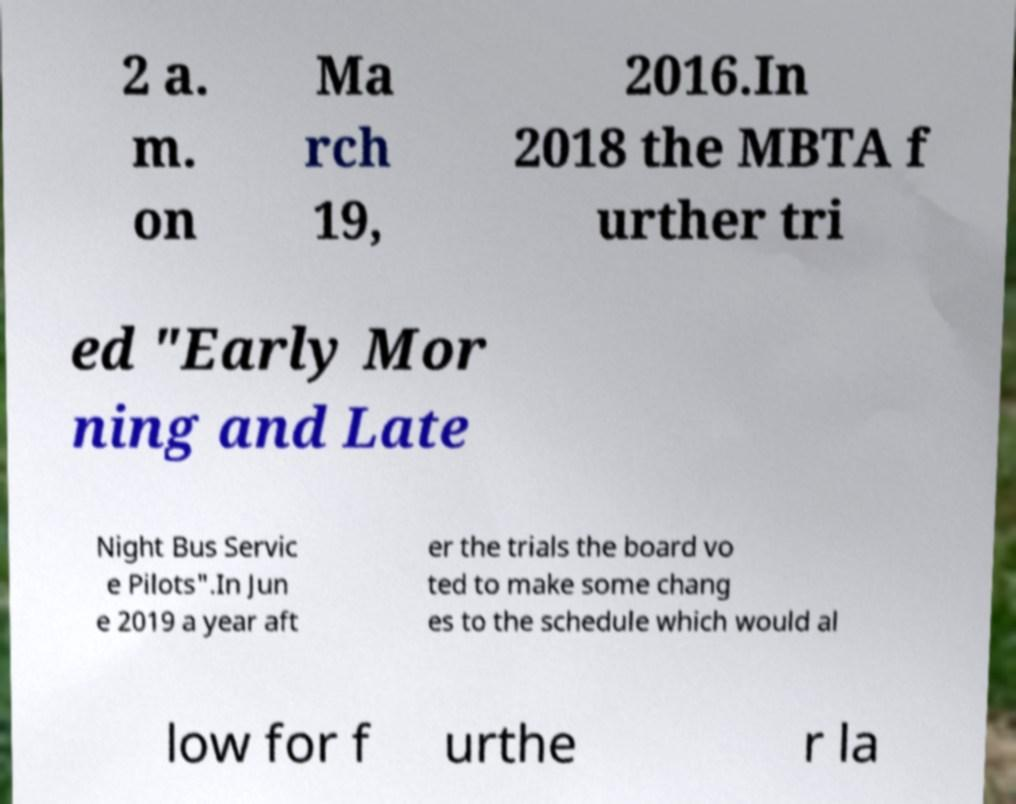I need the written content from this picture converted into text. Can you do that? 2 a. m. on Ma rch 19, 2016.In 2018 the MBTA f urther tri ed "Early Mor ning and Late Night Bus Servic e Pilots".In Jun e 2019 a year aft er the trials the board vo ted to make some chang es to the schedule which would al low for f urthe r la 